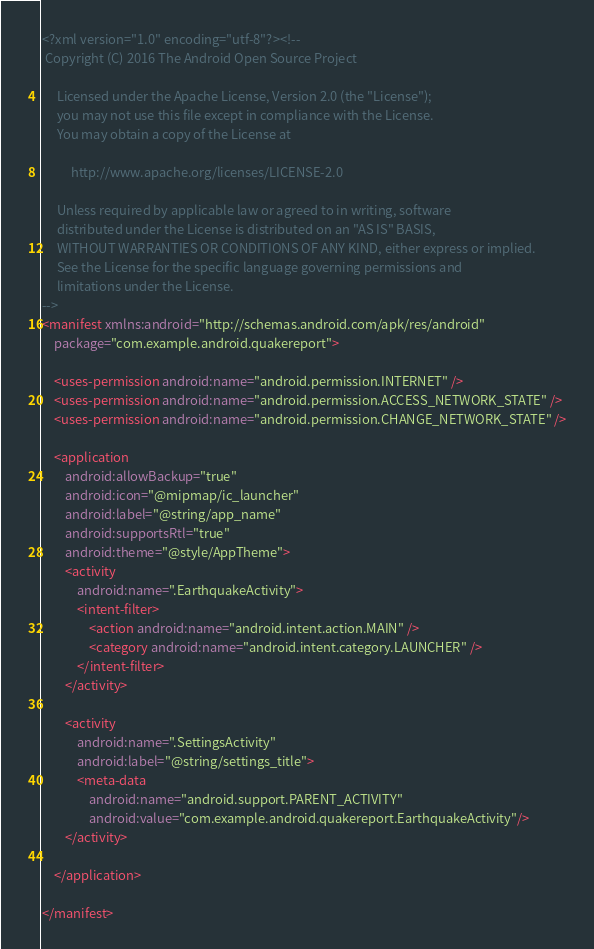<code> <loc_0><loc_0><loc_500><loc_500><_XML_><?xml version="1.0" encoding="utf-8"?><!--
 Copyright (C) 2016 The Android Open Source Project

     Licensed under the Apache License, Version 2.0 (the "License");
     you may not use this file except in compliance with the License.
     You may obtain a copy of the License at

          http://www.apache.org/licenses/LICENSE-2.0

     Unless required by applicable law or agreed to in writing, software
     distributed under the License is distributed on an "AS IS" BASIS,
     WITHOUT WARRANTIES OR CONDITIONS OF ANY KIND, either express or implied.
     See the License for the specific language governing permissions and
     limitations under the License.
-->
<manifest xmlns:android="http://schemas.android.com/apk/res/android"
    package="com.example.android.quakereport">

    <uses-permission android:name="android.permission.INTERNET" />
    <uses-permission android:name="android.permission.ACCESS_NETWORK_STATE" />
    <uses-permission android:name="android.permission.CHANGE_NETWORK_STATE" />

    <application
        android:allowBackup="true"
        android:icon="@mipmap/ic_launcher"
        android:label="@string/app_name"
        android:supportsRtl="true"
        android:theme="@style/AppTheme">
        <activity
            android:name=".EarthquakeActivity">
            <intent-filter>
                <action android:name="android.intent.action.MAIN" />
                <category android:name="android.intent.category.LAUNCHER" />
            </intent-filter>
        </activity>

        <activity
            android:name=".SettingsActivity"
            android:label="@string/settings_title">
            <meta-data
                android:name="android.support.PARENT_ACTIVITY"
                android:value="com.example.android.quakereport.EarthquakeActivity"/>
        </activity>

    </application>

</manifest></code> 